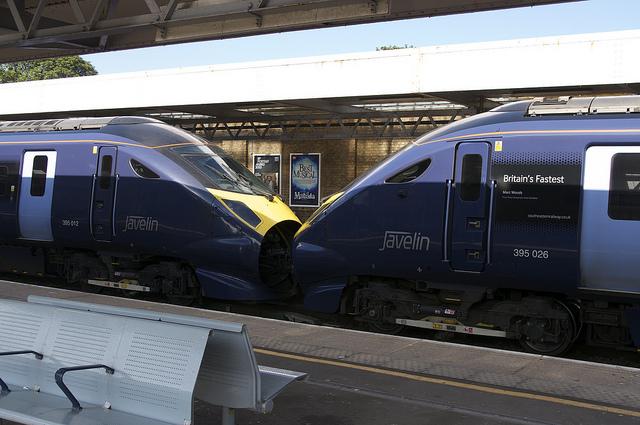Is anyone sitting on the benches?
Quick response, please. No. What color is the nose of the vehicle on the left?
Short answer required. Yellow. What word is written on the nose of the train?
Keep it brief. Javelin. 